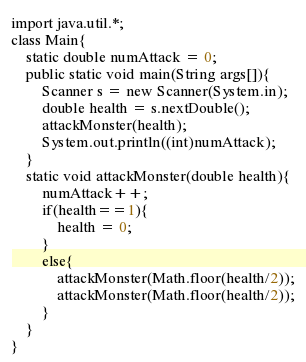<code> <loc_0><loc_0><loc_500><loc_500><_Java_>import java.util.*;
class Main{
    static double numAttack = 0;
	public static void main(String args[]){
    	Scanner s = new Scanner(System.in);
      	double health = s.nextDouble();
      	attackMonster(health);
      	System.out.println((int)numAttack);
    }
    static void attackMonster(double health){
        numAttack++;
        if(health==1){
            health = 0;
        }
        else{
            attackMonster(Math.floor(health/2));
            attackMonster(Math.floor(health/2));
        }
    }
}
</code> 